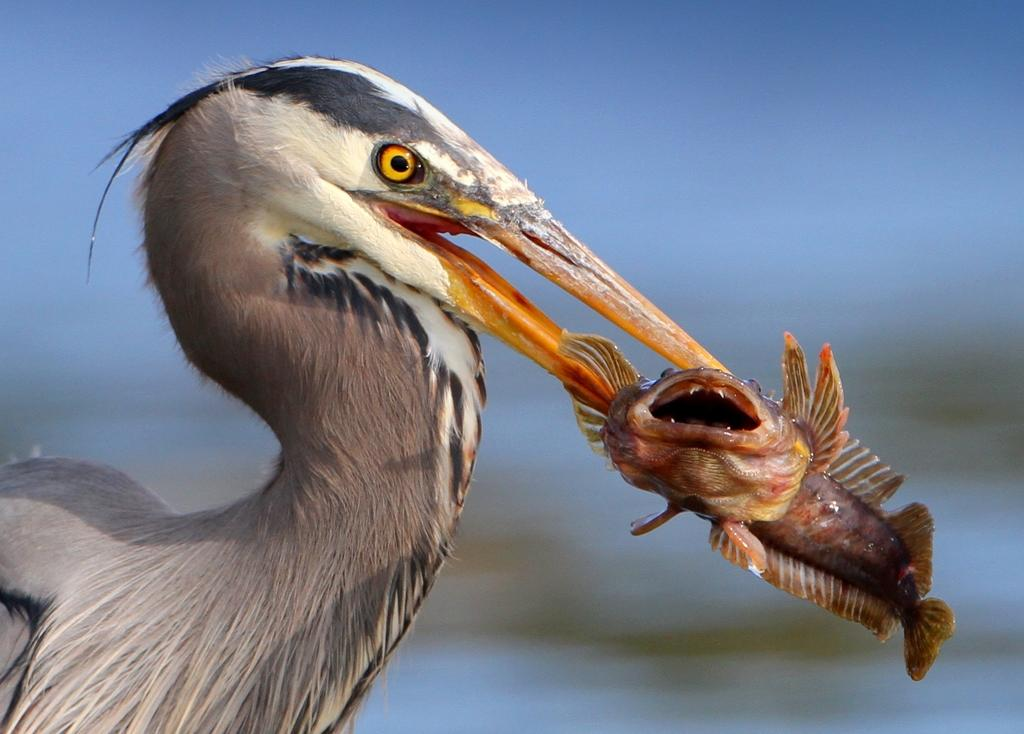What is the main subject of the image? The main subject of the image is a crane. What is the crane holding in the image? The crane is holding a fish. Can you describe the fish in the image? The fish has an orange beak. How would you describe the background of the image? The background of the image is blurry. What type of beam is being used by the bear in the image? There is no bear present in the image, and therefore no beam being used. How does the fire affect the fish in the image? There is no fire present in the image, so it does not affect the fish. 